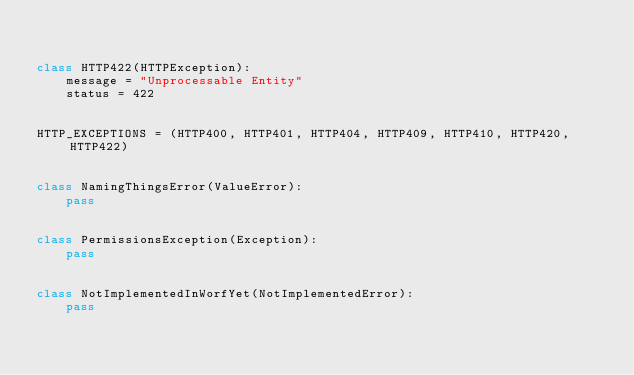<code> <loc_0><loc_0><loc_500><loc_500><_Python_>

class HTTP422(HTTPException):
    message = "Unprocessable Entity"
    status = 422


HTTP_EXCEPTIONS = (HTTP400, HTTP401, HTTP404, HTTP409, HTTP410, HTTP420, HTTP422)


class NamingThingsError(ValueError):
    pass


class PermissionsException(Exception):
    pass


class NotImplementedInWorfYet(NotImplementedError):
    pass
</code> 